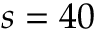Convert formula to latex. <formula><loc_0><loc_0><loc_500><loc_500>s = 4 0</formula> 